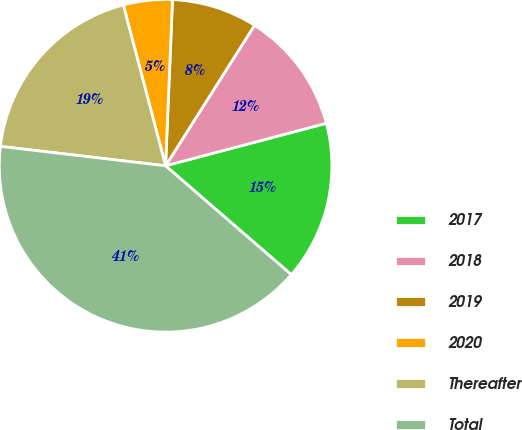<chart> <loc_0><loc_0><loc_500><loc_500><pie_chart><fcel>2017<fcel>2018<fcel>2019<fcel>2020<fcel>Thereafter<fcel>Total<nl><fcel>15.47%<fcel>11.9%<fcel>8.32%<fcel>4.75%<fcel>19.05%<fcel>40.5%<nl></chart> 